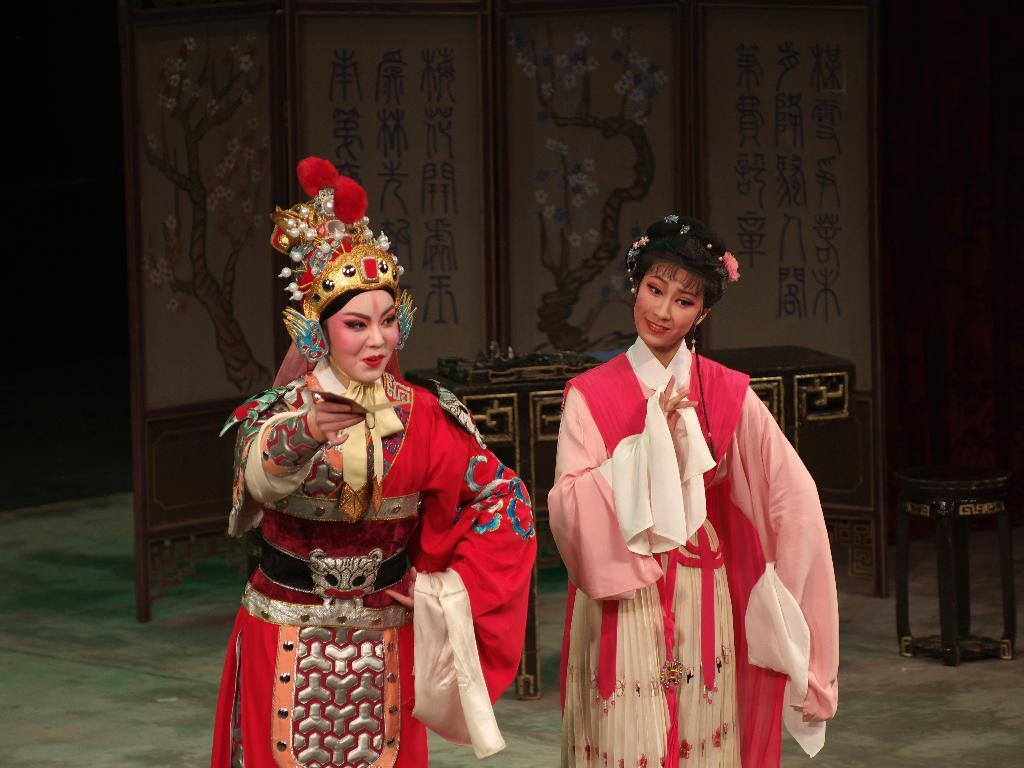How many people are in the image? There are two women in the image. What are the women doing in the image? The women are standing. What can be seen in the background of the image? There is a wooden wall in the background of the image. Is there any text or writing visible in the image? Yes, there is something written on the wooden wall. What is causing the increase in traffic downtown in the image? There is no reference to traffic or downtown in the image, so it's not possible to determine what might be causing an increase in traffic. 